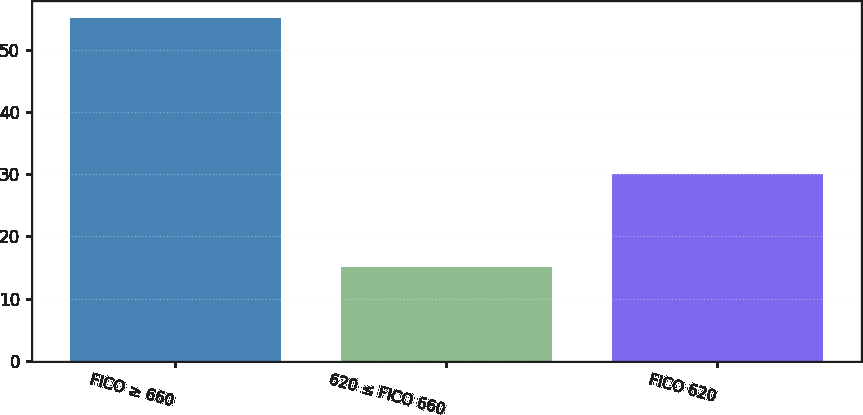Convert chart to OTSL. <chart><loc_0><loc_0><loc_500><loc_500><bar_chart><fcel>FICO ≥ 660<fcel>620 ≤ FICO 660<fcel>FICO 620<nl><fcel>55<fcel>15<fcel>30<nl></chart> 